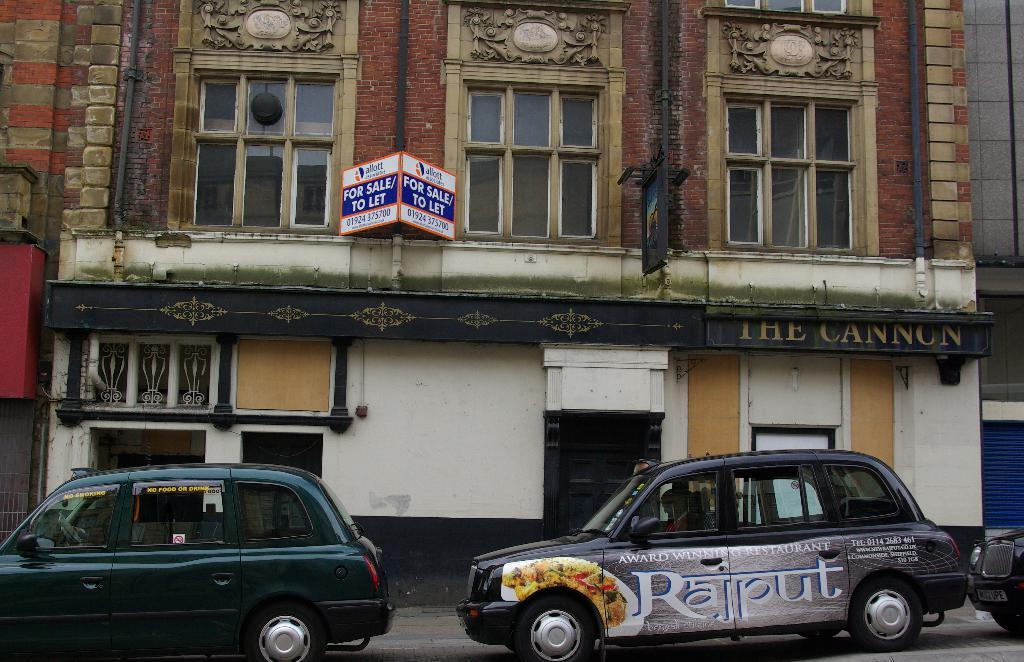<image>
Relay a brief, clear account of the picture shown. A car that says Rajput on the side is parked outside of The Cannon. 